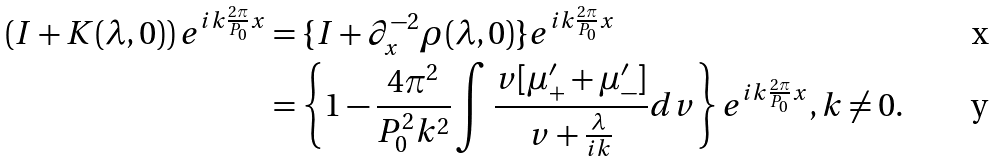Convert formula to latex. <formula><loc_0><loc_0><loc_500><loc_500>\left ( I + K ( \lambda , 0 ) \right ) e ^ { i k \frac { 2 \pi } { P _ { 0 } } x } & = \{ I + \partial _ { x } ^ { - 2 } \rho ( \lambda , 0 ) \} e ^ { i k \frac { 2 \pi } { P _ { 0 } } x } \\ & = \left \{ 1 - \frac { 4 \pi ^ { 2 } } { P _ { 0 } ^ { 2 } k ^ { 2 } } \int \frac { v [ \mu _ { + } ^ { \prime } + \mu _ { - } ^ { \prime } ] } { v + \frac { \lambda } { i k } } d v \right \} e ^ { i k \frac { 2 \pi } { P _ { 0 } } x } , k \neq 0 .</formula> 